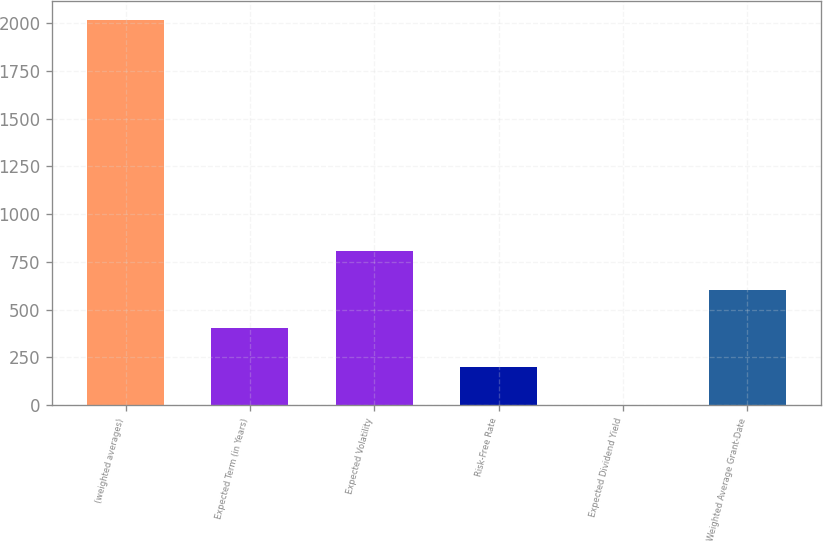Convert chart. <chart><loc_0><loc_0><loc_500><loc_500><bar_chart><fcel>(weighted averages)<fcel>Expected Term (in Years)<fcel>Expected Volatility<fcel>Risk-Free Rate<fcel>Expected Dividend Yield<fcel>Weighted Average Grant-Date<nl><fcel>2014<fcel>403.68<fcel>806.26<fcel>202.39<fcel>1.1<fcel>604.97<nl></chart> 